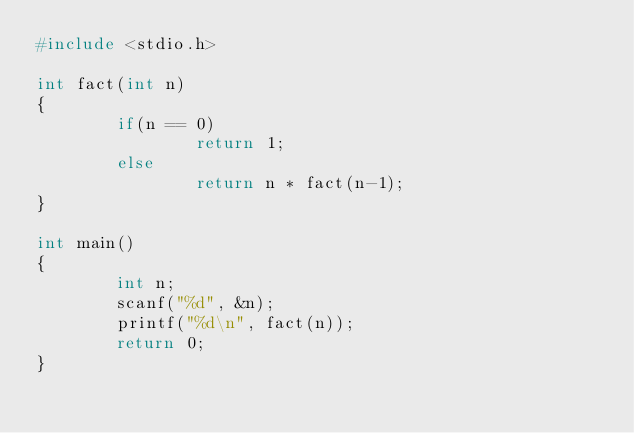Convert code to text. <code><loc_0><loc_0><loc_500><loc_500><_C_>#include <stdio.h>

int fact(int n)
{
        if(n == 0)
                return 1;
        else
                return n * fact(n-1);
}

int main()
{
        int n;
        scanf("%d", &n);
        printf("%d\n", fact(n));
        return 0;
}</code> 